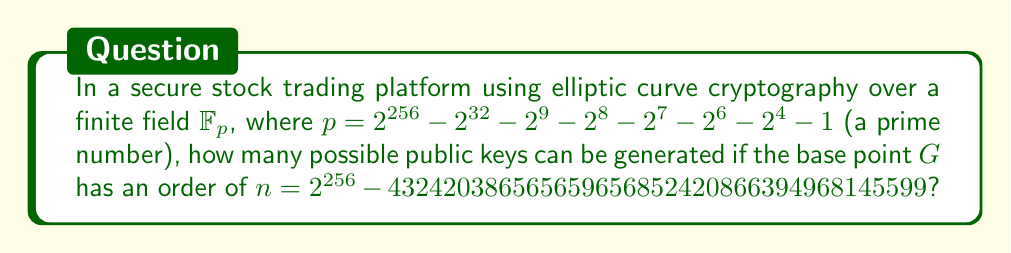Show me your answer to this math problem. To solve this problem, we need to understand the following concepts:

1. In elliptic curve cryptography (ECC), public keys are points on the curve.
2. The number of possible public keys is related to the order of the base point.

Step 1: Understand the finite field
The finite field $\mathbb{F}_p$ is defined by the prime $p$, which is a 256-bit prime number.

Step 2: Analyze the base point order
The order of the base point $G$ is given as $n$, which is slightly smaller than $2^{256}$.

Step 3: Determine the number of possible public keys
In ECC, public keys are generated by scalar multiplication of the base point:

$Q = kG$, where $k$ is the private key and $Q$ is the public key.

The number of possible public keys is equal to the order of the base point, $n$. This is because:
- $k$ can take any value from $1$ to $n-1$
- $nG = O$ (the point at infinity)
- Any value of $k$ greater than or equal to $n$ will result in a public key that has already been generated by a smaller $k$

Therefore, the number of possible public keys is exactly $n$.

Step 4: Express the answer
The number of possible public keys is:

$n = 2^{256} - 432420386565659656852420866394968145599$

This large number represents the security strength of the system, as it determines the difficulty of guessing a private key or finding collisions in public keys.
Answer: $2^{256} - 432420386565659656852420866394968145599$ 